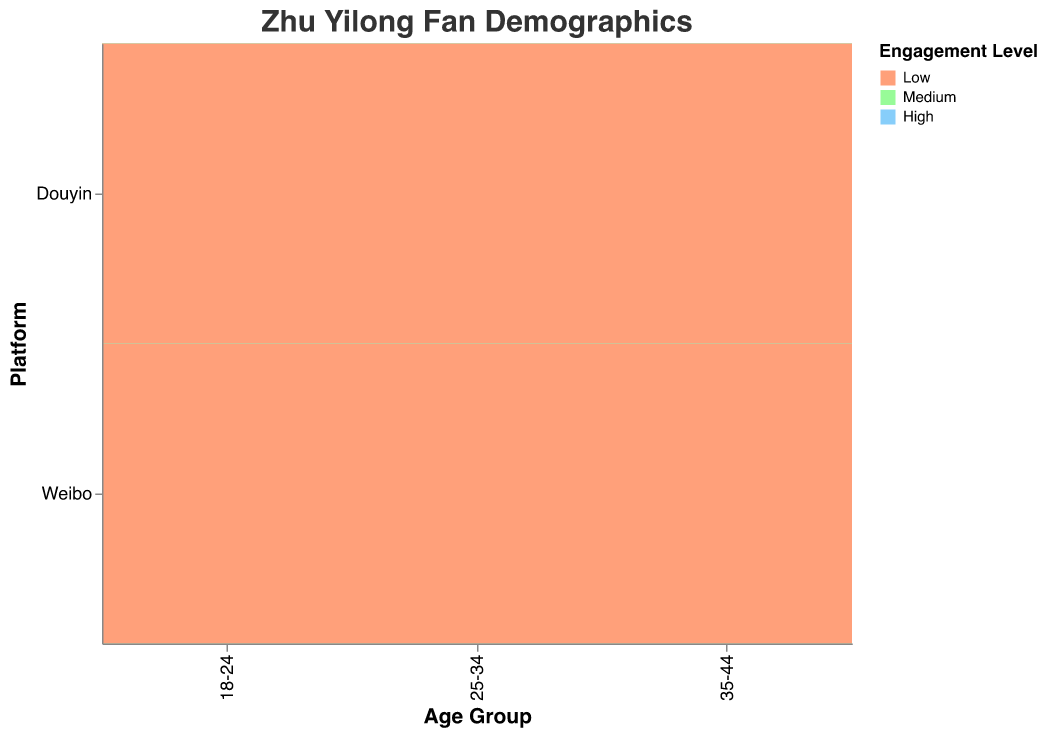What age group has the highest engagement level on Weibo? We need to look at the blocks corresponding to high engagement level on Weibo. The largest block is for the 25-34 age group.
Answer: 25-34 Which platform has more high engagement fans aged 35-44? Compare the size of the "High" engagement level blocks for age group 35-44 across both platforms. Weibo has a larger block than Douyin.
Answer: Weibo How many fans are there in the 18-24 age group with medium engagement levels on both platforms? Sum the counts for medium engagement levels: 3000 (Weibo) + 2000 (Douyin) = 5000
Answer: 5000 Is the number of low engagement level fans on Douyin for the age group 25-34 higher than that on Weibo? Compare the blocks for low engagement in age group 25-34 across the platforms. Douyin has 1000, while Weibo has 2000, so Weibo is higher.
Answer: No Which age group has the least number of medium engagement fans on Douyin? Compare the medium engagement blocks size for all age groups on Douyin. The 35-44 age group has 1500 fans in this category, the least compared to others.
Answer: 35-44 How does the engagement level distribution for the 18-24 age group compare between Weibo and Douyin? Weibo: High=5000, Medium=3000, Low=1000; Douyin: High=3000, Medium=2000, Low=500. Weibo has higher numbers in all categories.
Answer: Weibo has higher engagement What's the total number of high engagement level fans across all age groups on both platforms? Sum the counts of high engagement levels for both platforms and all age groups: 5000+8000+3000+3000+6000+2000 = 27000
Answer: 27000 Which engagement level has the smallest number of fans in the age group 25-34 on Weibo? Look at the Weibo blocks for 25-34: High=8000, Medium=4000, Low=2000. The smallest is Low engagement.
Answer: Low What is the ratio of high to low engagement fans aged 25-34 on Douyin? Calculate the counts and form the ratio: High=6000, Low=1000. The ratio is 6000:1000 or simplified to 6:1.
Answer: 6:1 